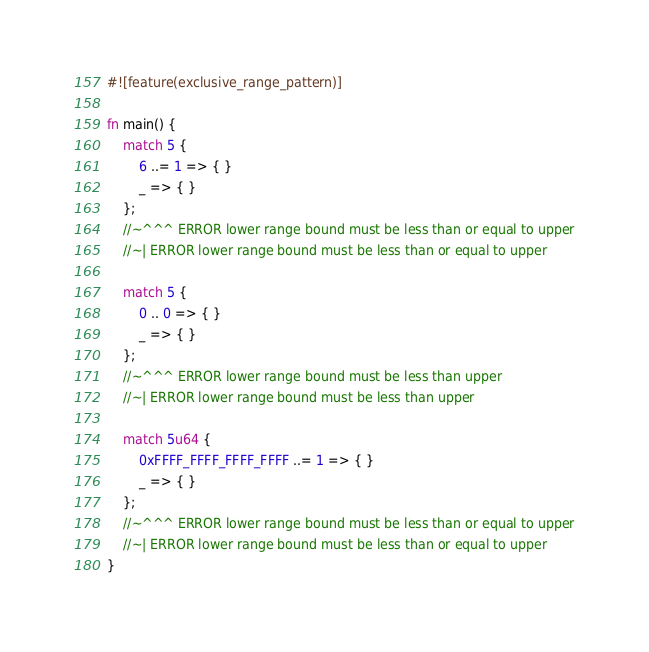Convert code to text. <code><loc_0><loc_0><loc_500><loc_500><_Rust_>#![feature(exclusive_range_pattern)]

fn main() {
    match 5 {
        6 ..= 1 => { }
        _ => { }
    };
    //~^^^ ERROR lower range bound must be less than or equal to upper
    //~| ERROR lower range bound must be less than or equal to upper

    match 5 {
        0 .. 0 => { }
        _ => { }
    };
    //~^^^ ERROR lower range bound must be less than upper
    //~| ERROR lower range bound must be less than upper

    match 5u64 {
        0xFFFF_FFFF_FFFF_FFFF ..= 1 => { }
        _ => { }
    };
    //~^^^ ERROR lower range bound must be less than or equal to upper
    //~| ERROR lower range bound must be less than or equal to upper
}
</code> 